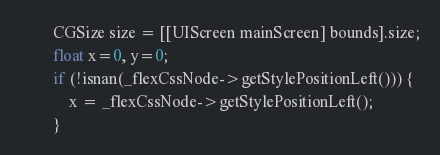Convert code to text. <code><loc_0><loc_0><loc_500><loc_500><_ObjectiveC_>        CGSize size = [[UIScreen mainScreen] bounds].size;
        float x=0, y=0;
        if (!isnan(_flexCssNode->getStylePositionLeft())) {
            x = _flexCssNode->getStylePositionLeft();
        }</code> 